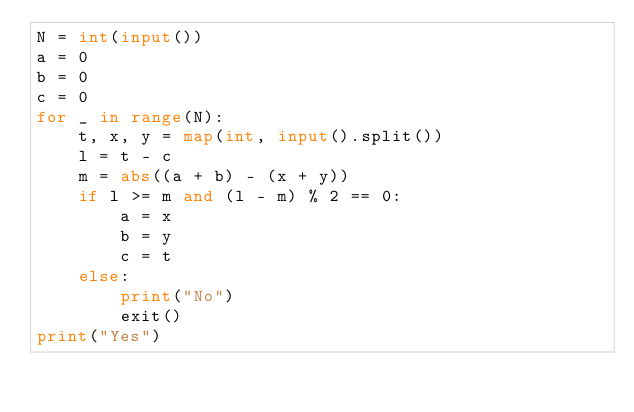<code> <loc_0><loc_0><loc_500><loc_500><_Python_>N = int(input())
a = 0
b = 0
c = 0
for _ in range(N):
    t, x, y = map(int, input().split())
    l = t - c
    m = abs((a + b) - (x + y))
    if l >= m and (l - m) % 2 == 0:
        a = x
        b = y
        c = t
    else:
        print("No")
        exit()
print("Yes")
</code> 